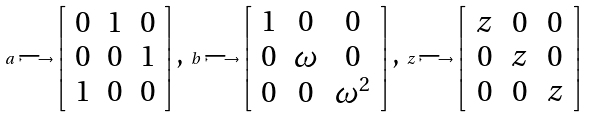Convert formula to latex. <formula><loc_0><loc_0><loc_500><loc_500>a \longmapsto \left [ \begin{array} { c c c } 0 & 1 & 0 \\ 0 & 0 & 1 \\ 1 & 0 & 0 \end{array} \right ] \text {, } b \longmapsto \left [ \begin{array} { c c c } 1 & 0 & 0 \\ 0 & \omega & 0 \\ 0 & 0 & \omega ^ { 2 } \end{array} \right ] \text {, } z \longmapsto \left [ \begin{array} { c c c } z & 0 & 0 \\ 0 & z & 0 \\ 0 & 0 & z \end{array} \right ]</formula> 